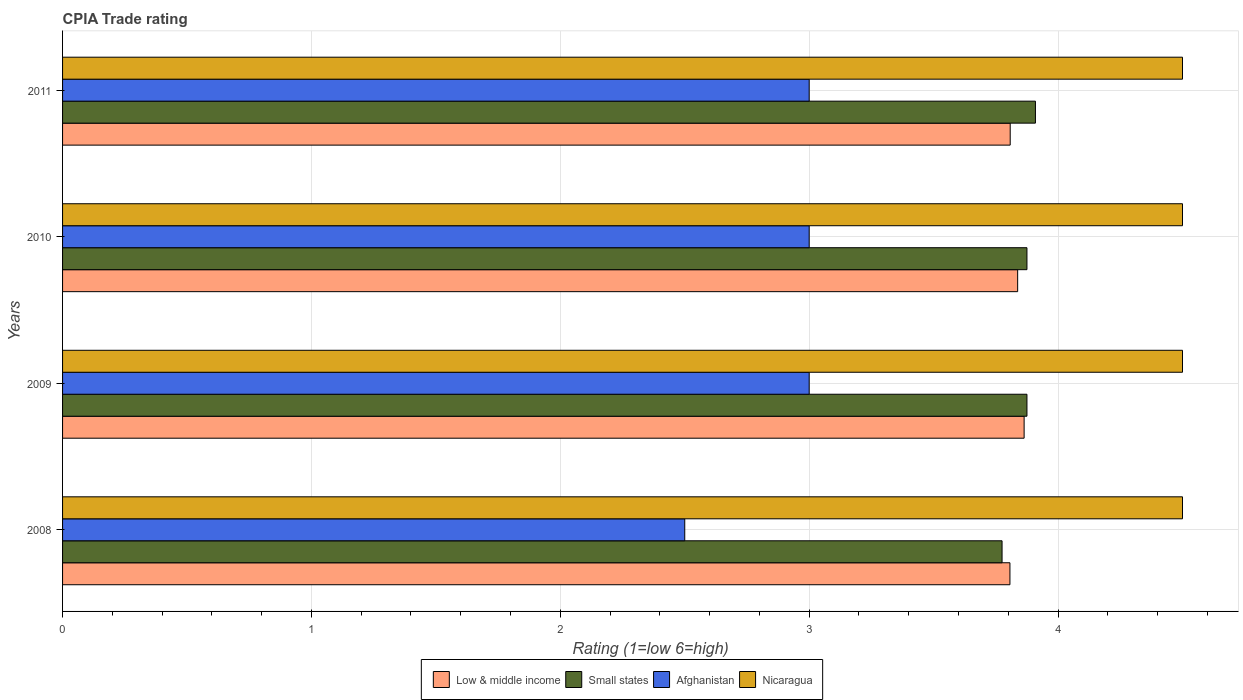How many different coloured bars are there?
Keep it short and to the point. 4. How many groups of bars are there?
Give a very brief answer. 4. Are the number of bars per tick equal to the number of legend labels?
Give a very brief answer. Yes. Are the number of bars on each tick of the Y-axis equal?
Your response must be concise. Yes. What is the label of the 4th group of bars from the top?
Provide a succinct answer. 2008. In how many cases, is the number of bars for a given year not equal to the number of legend labels?
Give a very brief answer. 0. What is the CPIA rating in Low & middle income in 2010?
Provide a succinct answer. 3.84. Across all years, what is the maximum CPIA rating in Low & middle income?
Offer a terse response. 3.86. Across all years, what is the minimum CPIA rating in Small states?
Your answer should be compact. 3.77. In which year was the CPIA rating in Nicaragua maximum?
Your answer should be compact. 2008. What is the total CPIA rating in Low & middle income in the graph?
Offer a terse response. 15.32. What is the difference between the CPIA rating in Nicaragua in 2010 and the CPIA rating in Low & middle income in 2008?
Provide a short and direct response. 0.69. What is the average CPIA rating in Small states per year?
Offer a terse response. 3.86. What is the ratio of the CPIA rating in Nicaragua in 2010 to that in 2011?
Ensure brevity in your answer.  1. Is the CPIA rating in Low & middle income in 2008 less than that in 2010?
Keep it short and to the point. Yes. Is the difference between the CPIA rating in Afghanistan in 2008 and 2009 greater than the difference between the CPIA rating in Nicaragua in 2008 and 2009?
Keep it short and to the point. No. What is the difference between the highest and the lowest CPIA rating in Afghanistan?
Provide a succinct answer. 0.5. In how many years, is the CPIA rating in Low & middle income greater than the average CPIA rating in Low & middle income taken over all years?
Offer a very short reply. 2. Is the sum of the CPIA rating in Nicaragua in 2010 and 2011 greater than the maximum CPIA rating in Low & middle income across all years?
Give a very brief answer. Yes. What does the 3rd bar from the top in 2011 represents?
Provide a short and direct response. Small states. What does the 3rd bar from the bottom in 2008 represents?
Provide a short and direct response. Afghanistan. Is it the case that in every year, the sum of the CPIA rating in Small states and CPIA rating in Low & middle income is greater than the CPIA rating in Afghanistan?
Ensure brevity in your answer.  Yes. Are all the bars in the graph horizontal?
Your response must be concise. Yes. How many years are there in the graph?
Your response must be concise. 4. What is the difference between two consecutive major ticks on the X-axis?
Your answer should be very brief. 1. Are the values on the major ticks of X-axis written in scientific E-notation?
Provide a short and direct response. No. How many legend labels are there?
Your answer should be compact. 4. How are the legend labels stacked?
Offer a very short reply. Horizontal. What is the title of the graph?
Your answer should be very brief. CPIA Trade rating. What is the label or title of the X-axis?
Your answer should be compact. Rating (1=low 6=high). What is the Rating (1=low 6=high) in Low & middle income in 2008?
Keep it short and to the point. 3.81. What is the Rating (1=low 6=high) of Small states in 2008?
Provide a succinct answer. 3.77. What is the Rating (1=low 6=high) of Low & middle income in 2009?
Ensure brevity in your answer.  3.86. What is the Rating (1=low 6=high) of Small states in 2009?
Keep it short and to the point. 3.88. What is the Rating (1=low 6=high) of Nicaragua in 2009?
Provide a short and direct response. 4.5. What is the Rating (1=low 6=high) in Low & middle income in 2010?
Offer a very short reply. 3.84. What is the Rating (1=low 6=high) of Small states in 2010?
Give a very brief answer. 3.88. What is the Rating (1=low 6=high) of Low & middle income in 2011?
Provide a short and direct response. 3.81. What is the Rating (1=low 6=high) in Small states in 2011?
Your answer should be compact. 3.91. What is the Rating (1=low 6=high) of Nicaragua in 2011?
Provide a short and direct response. 4.5. Across all years, what is the maximum Rating (1=low 6=high) of Low & middle income?
Give a very brief answer. 3.86. Across all years, what is the maximum Rating (1=low 6=high) of Small states?
Keep it short and to the point. 3.91. Across all years, what is the maximum Rating (1=low 6=high) of Afghanistan?
Offer a terse response. 3. Across all years, what is the maximum Rating (1=low 6=high) of Nicaragua?
Ensure brevity in your answer.  4.5. Across all years, what is the minimum Rating (1=low 6=high) in Low & middle income?
Make the answer very short. 3.81. Across all years, what is the minimum Rating (1=low 6=high) of Small states?
Keep it short and to the point. 3.77. Across all years, what is the minimum Rating (1=low 6=high) of Nicaragua?
Ensure brevity in your answer.  4.5. What is the total Rating (1=low 6=high) in Low & middle income in the graph?
Your answer should be compact. 15.32. What is the total Rating (1=low 6=high) of Small states in the graph?
Your answer should be very brief. 15.43. What is the total Rating (1=low 6=high) of Afghanistan in the graph?
Your answer should be very brief. 11.5. What is the difference between the Rating (1=low 6=high) in Low & middle income in 2008 and that in 2009?
Your response must be concise. -0.06. What is the difference between the Rating (1=low 6=high) of Afghanistan in 2008 and that in 2009?
Provide a short and direct response. -0.5. What is the difference between the Rating (1=low 6=high) of Low & middle income in 2008 and that in 2010?
Provide a succinct answer. -0.03. What is the difference between the Rating (1=low 6=high) of Small states in 2008 and that in 2010?
Your answer should be very brief. -0.1. What is the difference between the Rating (1=low 6=high) of Afghanistan in 2008 and that in 2010?
Provide a succinct answer. -0.5. What is the difference between the Rating (1=low 6=high) in Nicaragua in 2008 and that in 2010?
Give a very brief answer. 0. What is the difference between the Rating (1=low 6=high) in Low & middle income in 2008 and that in 2011?
Provide a succinct answer. -0. What is the difference between the Rating (1=low 6=high) in Small states in 2008 and that in 2011?
Your answer should be very brief. -0.13. What is the difference between the Rating (1=low 6=high) in Nicaragua in 2008 and that in 2011?
Make the answer very short. 0. What is the difference between the Rating (1=low 6=high) in Low & middle income in 2009 and that in 2010?
Offer a terse response. 0.03. What is the difference between the Rating (1=low 6=high) in Small states in 2009 and that in 2010?
Your answer should be compact. 0. What is the difference between the Rating (1=low 6=high) in Nicaragua in 2009 and that in 2010?
Your answer should be very brief. 0. What is the difference between the Rating (1=low 6=high) in Low & middle income in 2009 and that in 2011?
Make the answer very short. 0.06. What is the difference between the Rating (1=low 6=high) in Small states in 2009 and that in 2011?
Your response must be concise. -0.03. What is the difference between the Rating (1=low 6=high) in Small states in 2010 and that in 2011?
Make the answer very short. -0.03. What is the difference between the Rating (1=low 6=high) in Low & middle income in 2008 and the Rating (1=low 6=high) in Small states in 2009?
Make the answer very short. -0.07. What is the difference between the Rating (1=low 6=high) in Low & middle income in 2008 and the Rating (1=low 6=high) in Afghanistan in 2009?
Your response must be concise. 0.81. What is the difference between the Rating (1=low 6=high) in Low & middle income in 2008 and the Rating (1=low 6=high) in Nicaragua in 2009?
Keep it short and to the point. -0.69. What is the difference between the Rating (1=low 6=high) of Small states in 2008 and the Rating (1=low 6=high) of Afghanistan in 2009?
Make the answer very short. 0.78. What is the difference between the Rating (1=low 6=high) in Small states in 2008 and the Rating (1=low 6=high) in Nicaragua in 2009?
Offer a terse response. -0.72. What is the difference between the Rating (1=low 6=high) of Low & middle income in 2008 and the Rating (1=low 6=high) of Small states in 2010?
Give a very brief answer. -0.07. What is the difference between the Rating (1=low 6=high) of Low & middle income in 2008 and the Rating (1=low 6=high) of Afghanistan in 2010?
Give a very brief answer. 0.81. What is the difference between the Rating (1=low 6=high) in Low & middle income in 2008 and the Rating (1=low 6=high) in Nicaragua in 2010?
Your answer should be compact. -0.69. What is the difference between the Rating (1=low 6=high) of Small states in 2008 and the Rating (1=low 6=high) of Afghanistan in 2010?
Keep it short and to the point. 0.78. What is the difference between the Rating (1=low 6=high) in Small states in 2008 and the Rating (1=low 6=high) in Nicaragua in 2010?
Your answer should be very brief. -0.72. What is the difference between the Rating (1=low 6=high) in Low & middle income in 2008 and the Rating (1=low 6=high) in Small states in 2011?
Keep it short and to the point. -0.1. What is the difference between the Rating (1=low 6=high) of Low & middle income in 2008 and the Rating (1=low 6=high) of Afghanistan in 2011?
Provide a short and direct response. 0.81. What is the difference between the Rating (1=low 6=high) of Low & middle income in 2008 and the Rating (1=low 6=high) of Nicaragua in 2011?
Your response must be concise. -0.69. What is the difference between the Rating (1=low 6=high) of Small states in 2008 and the Rating (1=low 6=high) of Afghanistan in 2011?
Your answer should be very brief. 0.78. What is the difference between the Rating (1=low 6=high) of Small states in 2008 and the Rating (1=low 6=high) of Nicaragua in 2011?
Your answer should be very brief. -0.72. What is the difference between the Rating (1=low 6=high) in Afghanistan in 2008 and the Rating (1=low 6=high) in Nicaragua in 2011?
Provide a short and direct response. -2. What is the difference between the Rating (1=low 6=high) of Low & middle income in 2009 and the Rating (1=low 6=high) of Small states in 2010?
Offer a terse response. -0.01. What is the difference between the Rating (1=low 6=high) in Low & middle income in 2009 and the Rating (1=low 6=high) in Afghanistan in 2010?
Ensure brevity in your answer.  0.86. What is the difference between the Rating (1=low 6=high) of Low & middle income in 2009 and the Rating (1=low 6=high) of Nicaragua in 2010?
Make the answer very short. -0.64. What is the difference between the Rating (1=low 6=high) in Small states in 2009 and the Rating (1=low 6=high) in Nicaragua in 2010?
Provide a succinct answer. -0.62. What is the difference between the Rating (1=low 6=high) of Low & middle income in 2009 and the Rating (1=low 6=high) of Small states in 2011?
Make the answer very short. -0.05. What is the difference between the Rating (1=low 6=high) in Low & middle income in 2009 and the Rating (1=low 6=high) in Afghanistan in 2011?
Ensure brevity in your answer.  0.86. What is the difference between the Rating (1=low 6=high) in Low & middle income in 2009 and the Rating (1=low 6=high) in Nicaragua in 2011?
Provide a succinct answer. -0.64. What is the difference between the Rating (1=low 6=high) in Small states in 2009 and the Rating (1=low 6=high) in Nicaragua in 2011?
Provide a succinct answer. -0.62. What is the difference between the Rating (1=low 6=high) of Afghanistan in 2009 and the Rating (1=low 6=high) of Nicaragua in 2011?
Offer a very short reply. -1.5. What is the difference between the Rating (1=low 6=high) of Low & middle income in 2010 and the Rating (1=low 6=high) of Small states in 2011?
Your answer should be compact. -0.07. What is the difference between the Rating (1=low 6=high) in Low & middle income in 2010 and the Rating (1=low 6=high) in Afghanistan in 2011?
Offer a very short reply. 0.84. What is the difference between the Rating (1=low 6=high) of Low & middle income in 2010 and the Rating (1=low 6=high) of Nicaragua in 2011?
Keep it short and to the point. -0.66. What is the difference between the Rating (1=low 6=high) of Small states in 2010 and the Rating (1=low 6=high) of Nicaragua in 2011?
Make the answer very short. -0.62. What is the average Rating (1=low 6=high) in Low & middle income per year?
Make the answer very short. 3.83. What is the average Rating (1=low 6=high) in Small states per year?
Ensure brevity in your answer.  3.86. What is the average Rating (1=low 6=high) in Afghanistan per year?
Keep it short and to the point. 2.88. In the year 2008, what is the difference between the Rating (1=low 6=high) in Low & middle income and Rating (1=low 6=high) in Small states?
Your response must be concise. 0.03. In the year 2008, what is the difference between the Rating (1=low 6=high) of Low & middle income and Rating (1=low 6=high) of Afghanistan?
Your response must be concise. 1.31. In the year 2008, what is the difference between the Rating (1=low 6=high) in Low & middle income and Rating (1=low 6=high) in Nicaragua?
Make the answer very short. -0.69. In the year 2008, what is the difference between the Rating (1=low 6=high) of Small states and Rating (1=low 6=high) of Afghanistan?
Your answer should be very brief. 1.27. In the year 2008, what is the difference between the Rating (1=low 6=high) of Small states and Rating (1=low 6=high) of Nicaragua?
Make the answer very short. -0.72. In the year 2009, what is the difference between the Rating (1=low 6=high) in Low & middle income and Rating (1=low 6=high) in Small states?
Your response must be concise. -0.01. In the year 2009, what is the difference between the Rating (1=low 6=high) of Low & middle income and Rating (1=low 6=high) of Afghanistan?
Provide a short and direct response. 0.86. In the year 2009, what is the difference between the Rating (1=low 6=high) in Low & middle income and Rating (1=low 6=high) in Nicaragua?
Your response must be concise. -0.64. In the year 2009, what is the difference between the Rating (1=low 6=high) of Small states and Rating (1=low 6=high) of Afghanistan?
Provide a short and direct response. 0.88. In the year 2009, what is the difference between the Rating (1=low 6=high) in Small states and Rating (1=low 6=high) in Nicaragua?
Your answer should be compact. -0.62. In the year 2010, what is the difference between the Rating (1=low 6=high) in Low & middle income and Rating (1=low 6=high) in Small states?
Offer a terse response. -0.04. In the year 2010, what is the difference between the Rating (1=low 6=high) of Low & middle income and Rating (1=low 6=high) of Afghanistan?
Make the answer very short. 0.84. In the year 2010, what is the difference between the Rating (1=low 6=high) in Low & middle income and Rating (1=low 6=high) in Nicaragua?
Keep it short and to the point. -0.66. In the year 2010, what is the difference between the Rating (1=low 6=high) of Small states and Rating (1=low 6=high) of Afghanistan?
Give a very brief answer. 0.88. In the year 2010, what is the difference between the Rating (1=low 6=high) in Small states and Rating (1=low 6=high) in Nicaragua?
Offer a very short reply. -0.62. In the year 2010, what is the difference between the Rating (1=low 6=high) of Afghanistan and Rating (1=low 6=high) of Nicaragua?
Give a very brief answer. -1.5. In the year 2011, what is the difference between the Rating (1=low 6=high) of Low & middle income and Rating (1=low 6=high) of Small states?
Offer a very short reply. -0.1. In the year 2011, what is the difference between the Rating (1=low 6=high) in Low & middle income and Rating (1=low 6=high) in Afghanistan?
Your answer should be very brief. 0.81. In the year 2011, what is the difference between the Rating (1=low 6=high) of Low & middle income and Rating (1=low 6=high) of Nicaragua?
Give a very brief answer. -0.69. In the year 2011, what is the difference between the Rating (1=low 6=high) in Small states and Rating (1=low 6=high) in Nicaragua?
Give a very brief answer. -0.59. What is the ratio of the Rating (1=low 6=high) of Low & middle income in 2008 to that in 2009?
Your response must be concise. 0.99. What is the ratio of the Rating (1=low 6=high) in Small states in 2008 to that in 2009?
Provide a short and direct response. 0.97. What is the ratio of the Rating (1=low 6=high) in Afghanistan in 2008 to that in 2009?
Your response must be concise. 0.83. What is the ratio of the Rating (1=low 6=high) of Nicaragua in 2008 to that in 2009?
Provide a succinct answer. 1. What is the ratio of the Rating (1=low 6=high) of Small states in 2008 to that in 2010?
Your answer should be compact. 0.97. What is the ratio of the Rating (1=low 6=high) of Nicaragua in 2008 to that in 2010?
Give a very brief answer. 1. What is the ratio of the Rating (1=low 6=high) in Small states in 2008 to that in 2011?
Provide a short and direct response. 0.97. What is the ratio of the Rating (1=low 6=high) of Low & middle income in 2009 to that in 2010?
Your response must be concise. 1.01. What is the ratio of the Rating (1=low 6=high) of Nicaragua in 2009 to that in 2010?
Ensure brevity in your answer.  1. What is the ratio of the Rating (1=low 6=high) of Low & middle income in 2009 to that in 2011?
Offer a terse response. 1.01. What is the ratio of the Rating (1=low 6=high) of Afghanistan in 2009 to that in 2011?
Provide a succinct answer. 1. What is the ratio of the Rating (1=low 6=high) of Low & middle income in 2010 to that in 2011?
Make the answer very short. 1.01. What is the ratio of the Rating (1=low 6=high) in Small states in 2010 to that in 2011?
Keep it short and to the point. 0.99. What is the ratio of the Rating (1=low 6=high) of Nicaragua in 2010 to that in 2011?
Keep it short and to the point. 1. What is the difference between the highest and the second highest Rating (1=low 6=high) in Low & middle income?
Your answer should be compact. 0.03. What is the difference between the highest and the second highest Rating (1=low 6=high) in Small states?
Your answer should be very brief. 0.03. What is the difference between the highest and the second highest Rating (1=low 6=high) in Afghanistan?
Offer a terse response. 0. What is the difference between the highest and the lowest Rating (1=low 6=high) in Low & middle income?
Provide a short and direct response. 0.06. What is the difference between the highest and the lowest Rating (1=low 6=high) of Small states?
Keep it short and to the point. 0.13. What is the difference between the highest and the lowest Rating (1=low 6=high) in Afghanistan?
Provide a succinct answer. 0.5. 